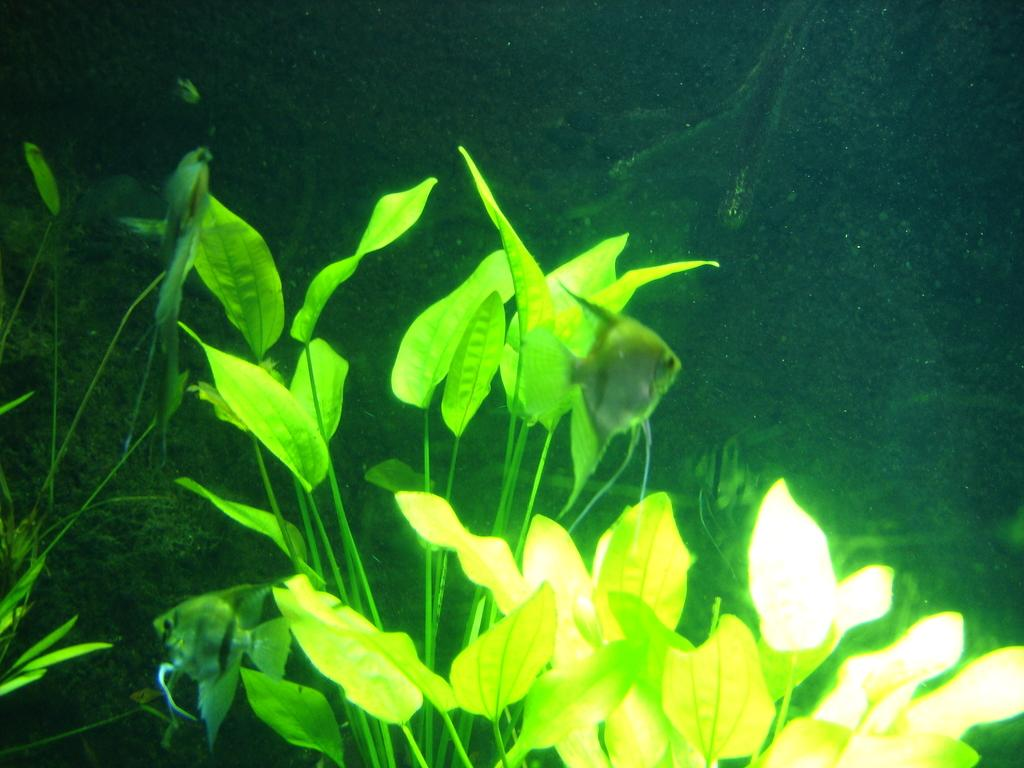What is located in the center of the image? There are leaves in the center of the image. What can be seen swimming in the water in the image? There are fishes swimming in the water. What else is visible in the background of the image? There are other objects visible in the background of the image. What type of zephyr can be seen blowing through the leaves in the image? There is no zephyr present in the image; it is a natural phenomenon and not a visible object. How does the sleet affect the fishes swimming in the water in the image? There is no sleet present in the image; it is a type of precipitation and not a visible object. 